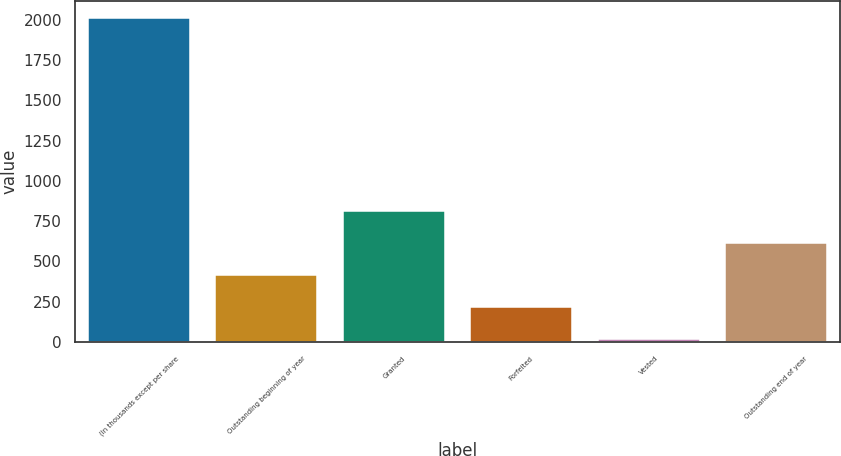Convert chart to OTSL. <chart><loc_0><loc_0><loc_500><loc_500><bar_chart><fcel>(In thousands except per share<fcel>Outstanding beginning of year<fcel>Granted<fcel>Forfeited<fcel>Vested<fcel>Outstanding end of year<nl><fcel>2013<fcel>416<fcel>815.24<fcel>216.38<fcel>16.76<fcel>615.62<nl></chart> 